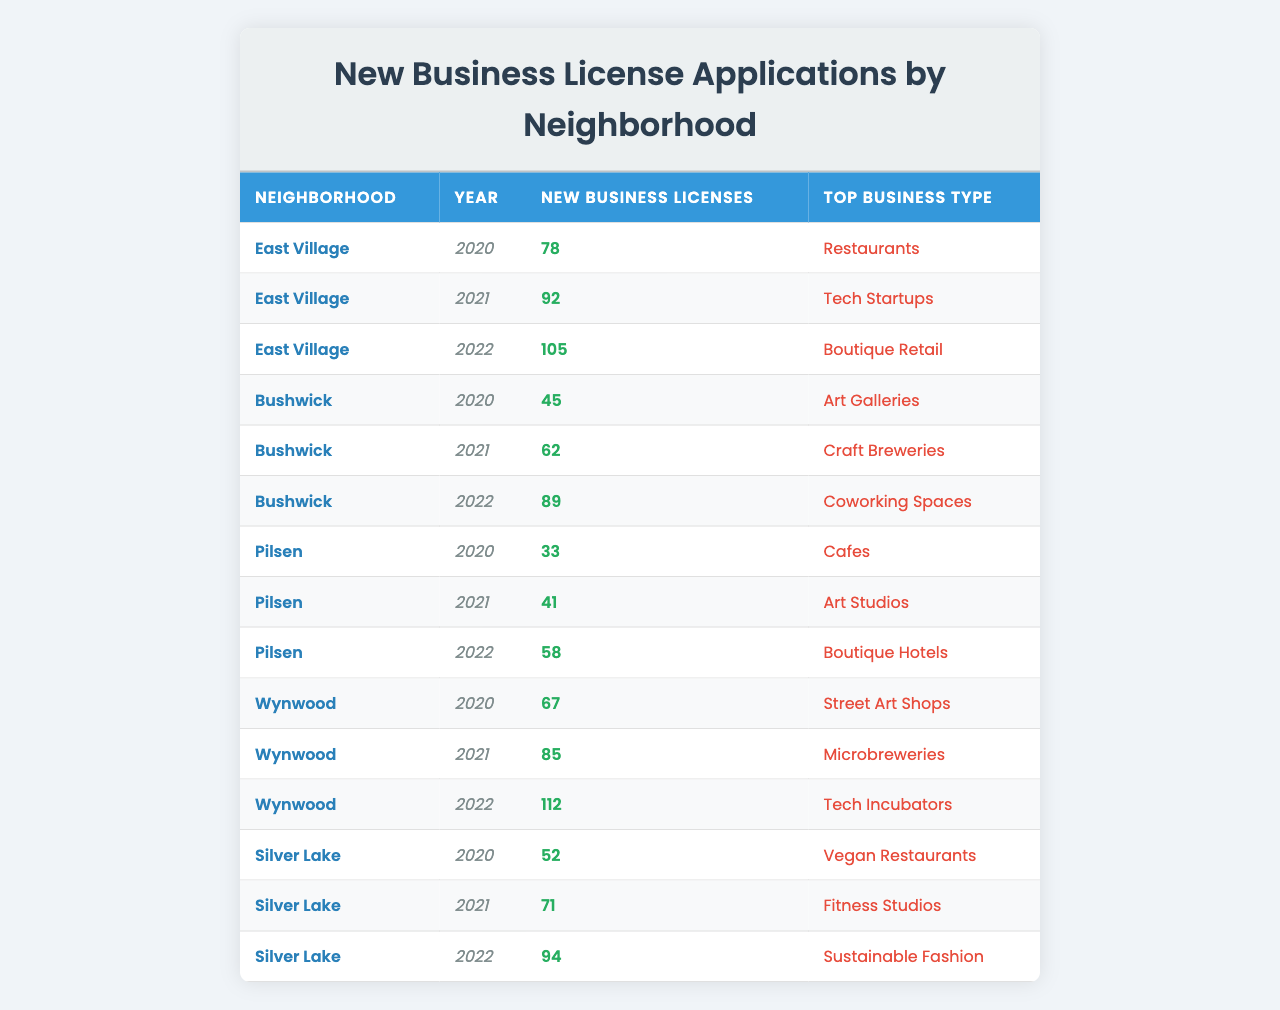What neighborhood had the highest number of new business licenses in 2022? In 2022, the neighborhoods listed are East Village (105), Bushwick (89), Pilsen (58), Wynwood (112), and Silver Lake (94). Comparing these values, Wynwood has the highest number, with 112 new business licenses.
Answer: Wynwood How many new business licenses were issued in Bushwick in total over the three years? The total for Bushwick over the three years is calculated by adding the annual figures: 45 (2020) + 62 (2021) + 89 (2022) = 196.
Answer: 196 Which business type was the top in East Village in 2021? According to the table, the top business type in East Village for the year 2021 is listed as "Tech Startups."
Answer: Tech Startups Was there a year when Pilsen had the same number of new business licenses as Bushwick? Pilsen had 33 (2020), 41 (2021), and 58 (2022) while Bushwick had 45 (2020), 62 (2021), and 89 (2022). None of these values are equal across the years.
Answer: No What was the increase in new business licenses from 2020 to 2022 in Silver Lake? For Silver Lake, the new business licenses in 2020 were 52, and in 2022 were 94. The increase is calculated as 94 - 52 = 42.
Answer: 42 Which neighborhood saw the largest growth in new business licenses from 2020 to 2021? To determine growth from 2020 to 2021, we compare the difference for each neighborhood: East Village (92 - 78 = 14), Bushwick (62 - 45 = 17), Pilsen (41 - 33 = 8), Wynwood (85 - 67 = 18), and Silver Lake (71 - 52 = 19). The largest growth is in Silver Lake with an increase of 19.
Answer: Silver Lake Is the top business type for Wynwood the same across all three years? Wynwood’s top business types are "Street Art Shops" (2020), "Microbreweries" (2021), and "Tech Incubators" (2022). Since these are different, the answer is no.
Answer: No What was the average number of new business licenses issued in East Village from 2020 to 2022? The average is calculated by summing the annual numbers (78 + 92 + 105) = 275 and then dividing by the number of years (3): 275 / 3 = approximately 91.67, which we can round to 92.
Answer: 92 Which neighborhood had the smallest number of new business licenses in 2020? In 2020, the numbers for each neighborhood are East Village (78), Bushwick (45), Pilsen (33), Wynwood (67), and Silver Lake (52). The smallest number is in Pilsen with 33.
Answer: Pilsen 